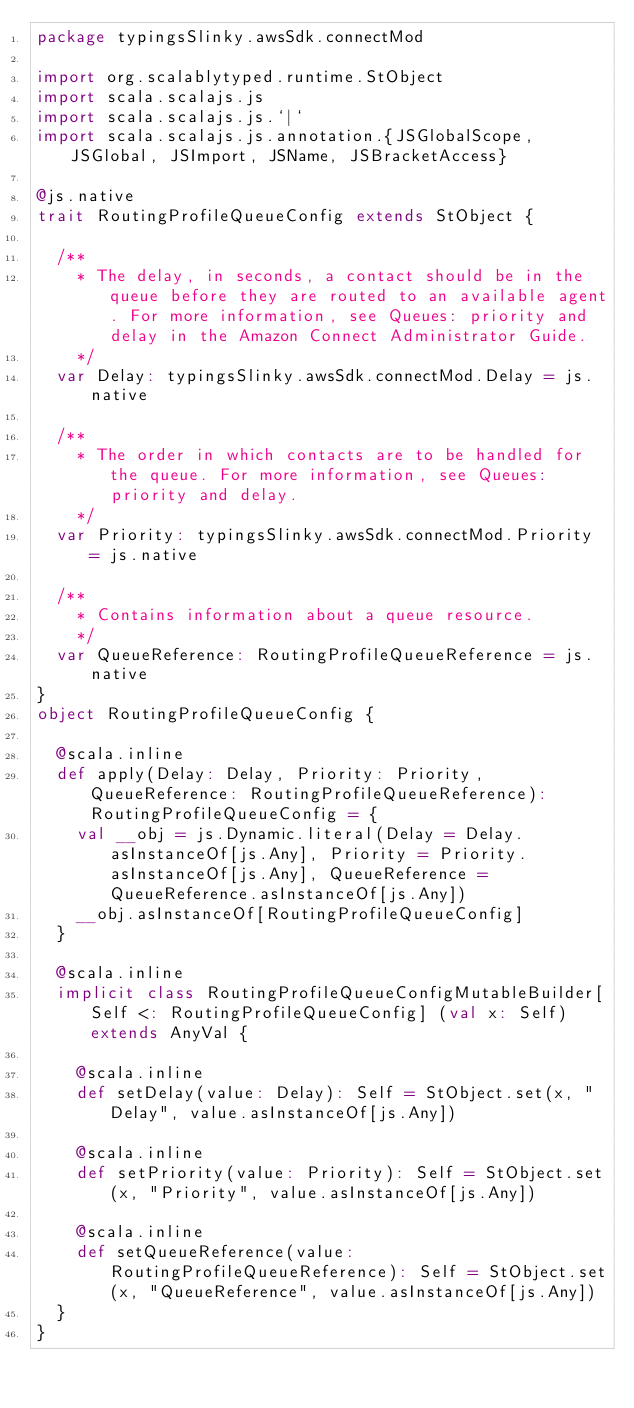<code> <loc_0><loc_0><loc_500><loc_500><_Scala_>package typingsSlinky.awsSdk.connectMod

import org.scalablytyped.runtime.StObject
import scala.scalajs.js
import scala.scalajs.js.`|`
import scala.scalajs.js.annotation.{JSGlobalScope, JSGlobal, JSImport, JSName, JSBracketAccess}

@js.native
trait RoutingProfileQueueConfig extends StObject {
  
  /**
    * The delay, in seconds, a contact should be in the queue before they are routed to an available agent. For more information, see Queues: priority and delay in the Amazon Connect Administrator Guide.
    */
  var Delay: typingsSlinky.awsSdk.connectMod.Delay = js.native
  
  /**
    * The order in which contacts are to be handled for the queue. For more information, see Queues: priority and delay.
    */
  var Priority: typingsSlinky.awsSdk.connectMod.Priority = js.native
  
  /**
    * Contains information about a queue resource.
    */
  var QueueReference: RoutingProfileQueueReference = js.native
}
object RoutingProfileQueueConfig {
  
  @scala.inline
  def apply(Delay: Delay, Priority: Priority, QueueReference: RoutingProfileQueueReference): RoutingProfileQueueConfig = {
    val __obj = js.Dynamic.literal(Delay = Delay.asInstanceOf[js.Any], Priority = Priority.asInstanceOf[js.Any], QueueReference = QueueReference.asInstanceOf[js.Any])
    __obj.asInstanceOf[RoutingProfileQueueConfig]
  }
  
  @scala.inline
  implicit class RoutingProfileQueueConfigMutableBuilder[Self <: RoutingProfileQueueConfig] (val x: Self) extends AnyVal {
    
    @scala.inline
    def setDelay(value: Delay): Self = StObject.set(x, "Delay", value.asInstanceOf[js.Any])
    
    @scala.inline
    def setPriority(value: Priority): Self = StObject.set(x, "Priority", value.asInstanceOf[js.Any])
    
    @scala.inline
    def setQueueReference(value: RoutingProfileQueueReference): Self = StObject.set(x, "QueueReference", value.asInstanceOf[js.Any])
  }
}
</code> 